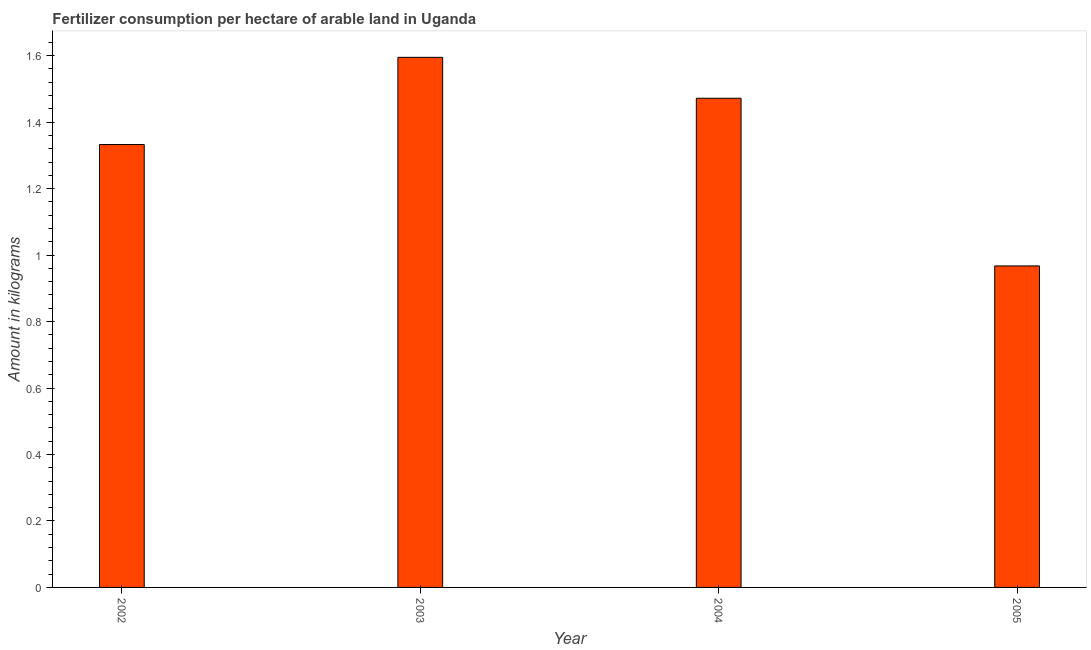Does the graph contain any zero values?
Give a very brief answer. No. What is the title of the graph?
Make the answer very short. Fertilizer consumption per hectare of arable land in Uganda . What is the label or title of the Y-axis?
Offer a very short reply. Amount in kilograms. What is the amount of fertilizer consumption in 2002?
Make the answer very short. 1.33. Across all years, what is the maximum amount of fertilizer consumption?
Make the answer very short. 1.6. Across all years, what is the minimum amount of fertilizer consumption?
Offer a very short reply. 0.97. In which year was the amount of fertilizer consumption maximum?
Ensure brevity in your answer.  2003. What is the sum of the amount of fertilizer consumption?
Make the answer very short. 5.37. What is the difference between the amount of fertilizer consumption in 2002 and 2005?
Give a very brief answer. 0.36. What is the average amount of fertilizer consumption per year?
Your answer should be very brief. 1.34. What is the median amount of fertilizer consumption?
Your answer should be very brief. 1.4. In how many years, is the amount of fertilizer consumption greater than 1.44 kg?
Ensure brevity in your answer.  2. Do a majority of the years between 2002 and 2005 (inclusive) have amount of fertilizer consumption greater than 1.48 kg?
Your answer should be compact. No. What is the ratio of the amount of fertilizer consumption in 2003 to that in 2004?
Offer a terse response. 1.08. Is the amount of fertilizer consumption in 2004 less than that in 2005?
Provide a succinct answer. No. Is the difference between the amount of fertilizer consumption in 2002 and 2003 greater than the difference between any two years?
Make the answer very short. No. What is the difference between the highest and the second highest amount of fertilizer consumption?
Give a very brief answer. 0.12. What is the difference between the highest and the lowest amount of fertilizer consumption?
Ensure brevity in your answer.  0.63. Are all the bars in the graph horizontal?
Your response must be concise. No. How many years are there in the graph?
Offer a very short reply. 4. What is the difference between two consecutive major ticks on the Y-axis?
Your answer should be very brief. 0.2. Are the values on the major ticks of Y-axis written in scientific E-notation?
Give a very brief answer. No. What is the Amount in kilograms in 2002?
Your answer should be very brief. 1.33. What is the Amount in kilograms in 2003?
Your answer should be very brief. 1.6. What is the Amount in kilograms of 2004?
Make the answer very short. 1.47. What is the Amount in kilograms in 2005?
Provide a succinct answer. 0.97. What is the difference between the Amount in kilograms in 2002 and 2003?
Ensure brevity in your answer.  -0.26. What is the difference between the Amount in kilograms in 2002 and 2004?
Make the answer very short. -0.14. What is the difference between the Amount in kilograms in 2002 and 2005?
Your answer should be very brief. 0.37. What is the difference between the Amount in kilograms in 2003 and 2004?
Provide a succinct answer. 0.12. What is the difference between the Amount in kilograms in 2003 and 2005?
Offer a very short reply. 0.63. What is the difference between the Amount in kilograms in 2004 and 2005?
Your answer should be compact. 0.5. What is the ratio of the Amount in kilograms in 2002 to that in 2003?
Offer a very short reply. 0.84. What is the ratio of the Amount in kilograms in 2002 to that in 2004?
Provide a short and direct response. 0.91. What is the ratio of the Amount in kilograms in 2002 to that in 2005?
Your answer should be compact. 1.38. What is the ratio of the Amount in kilograms in 2003 to that in 2004?
Provide a short and direct response. 1.08. What is the ratio of the Amount in kilograms in 2003 to that in 2005?
Offer a very short reply. 1.65. What is the ratio of the Amount in kilograms in 2004 to that in 2005?
Ensure brevity in your answer.  1.52. 